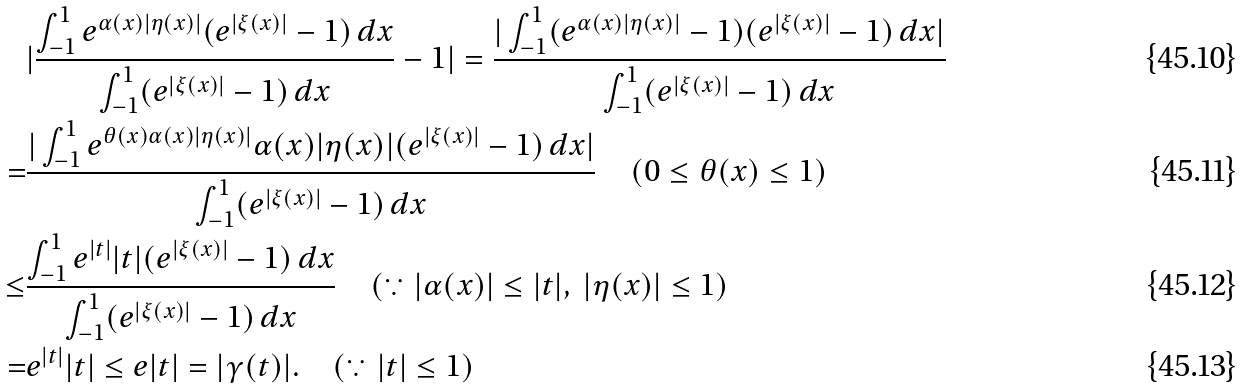Convert formula to latex. <formula><loc_0><loc_0><loc_500><loc_500>& | \frac { \int _ { - 1 } ^ { 1 } e ^ { \alpha ( x ) | \eta ( x ) | } ( e ^ { | \xi ( x ) | } - 1 ) \, d x } { \int _ { - 1 } ^ { 1 } ( e ^ { | \xi ( x ) | } - 1 ) \, d x } - 1 | = \frac { | \int _ { - 1 } ^ { 1 } ( e ^ { \alpha ( x ) | \eta ( x ) | } - 1 ) ( e ^ { | \xi ( x ) | } - 1 ) \, d x | } { \int _ { - 1 } ^ { 1 } ( e ^ { | \xi ( x ) | } - 1 ) \, d x } \\ = & \frac { | \int _ { - 1 } ^ { 1 } e ^ { \theta ( x ) \alpha ( x ) | \eta ( x ) | } \alpha ( x ) | \eta ( x ) | ( e ^ { | \xi ( x ) | } - 1 ) \, d x | } { \int _ { - 1 } ^ { 1 } ( e ^ { | \xi ( x ) | } - 1 ) \, d x } \quad ( 0 \leq \theta ( x ) \leq 1 ) \\ \leq & \frac { \int _ { - 1 } ^ { 1 } e ^ { | t | } | t | ( e ^ { | \xi ( x ) | } - 1 ) \, d x } { \int _ { - 1 } ^ { 1 } ( e ^ { | \xi ( x ) | } - 1 ) \, d x } \quad ( \because | \alpha ( x ) | \leq | t | , \ | \eta ( x ) | \leq 1 ) \\ = & e ^ { | t | } | t | \leq e | t | = | \gamma ( t ) | . \quad ( \because | t | \leq 1 )</formula> 